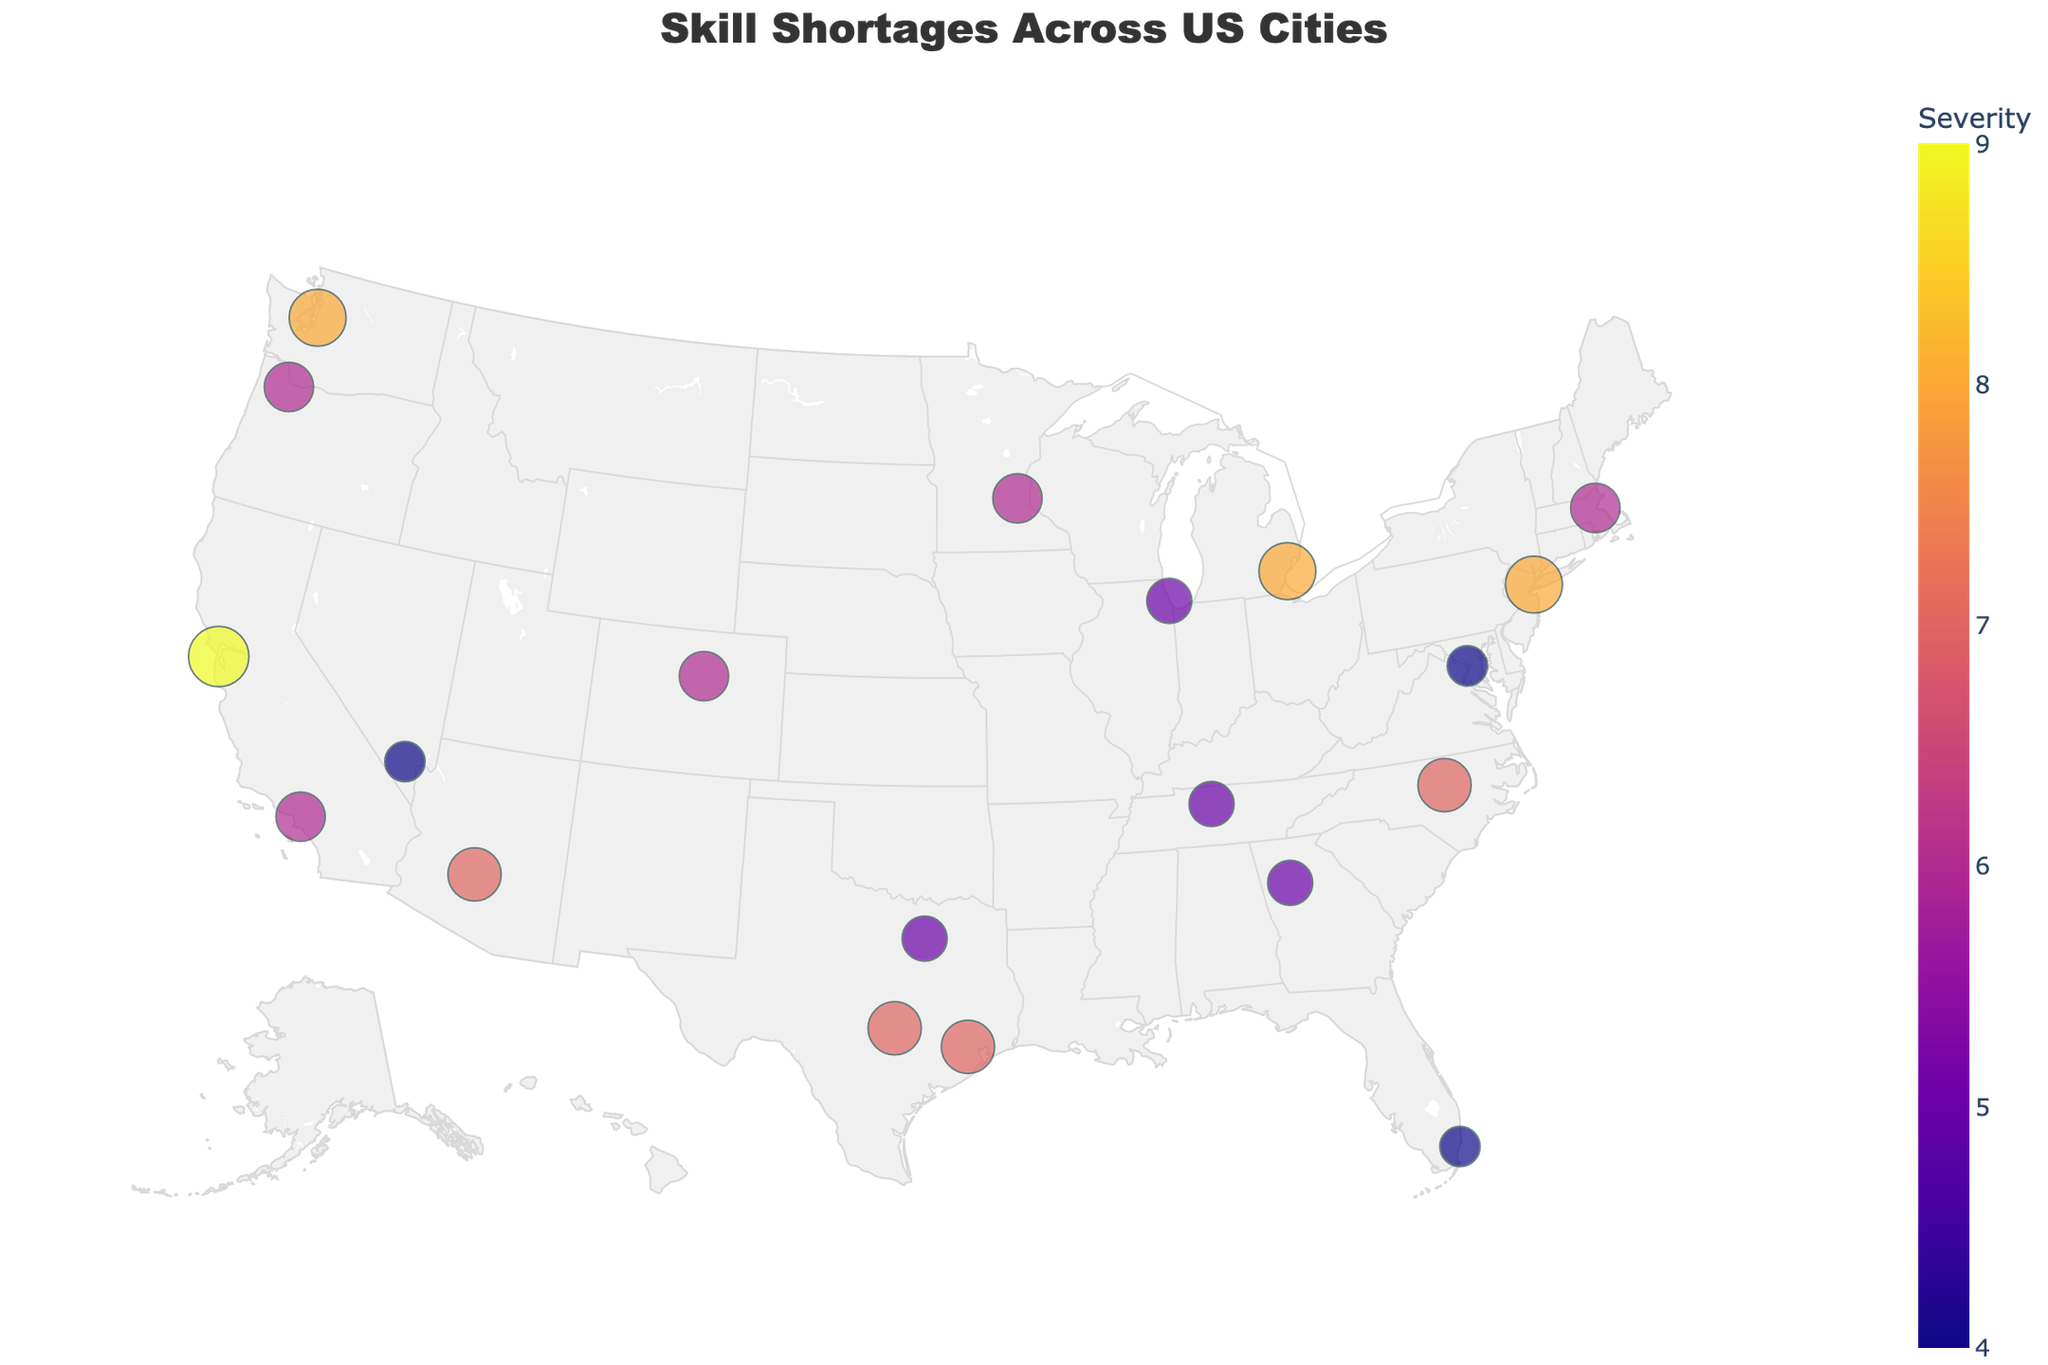What's the title of the plot? The title of the plot is prominently displayed at the top. It helps provide context for what the figure is about.
Answer: Skill Shortages Across US Cities Which city has the highest severity of skill shortages? By looking at the color scale and size of the markers, the city with the highest value on the color scale and the largest marker corresponds to the highest severity.
Answer: San Francisco What skill shortage is identified in New York City, and how severe is it? Hovering over New York City reveals a tooltip with additional information.
Answer: Data Scientists, Severity: 8 Which city has a skill shortage with a severity level of 5? By checking the color and size of the markers, we can identify cities that have the same severity level.
Answer: Chicago, Atlanta, Nashville, Dallas Compare the severity of skill shortages between Boston and Miami. We can compare the color and size of the markers for both cities to determine the severity levels. Boston has a severity marker of 6, while Miami has a severity marker of 4, indicating Boston has a more severe shortage.
Answer: Boston (6) > Miami (4) How many cities have a skill shortage severity level greater than 6? By scanning the markers and their corresponding color and size, we count the cities with severity levels of 7 and above: San Francisco, New York City, Austin, Houston, Phoenix, and Detroit.
Answer: 6 cities What trend can be observed regarding the types of skill shortages in different regions? Observing the types of skill shortages listed in various regions can help identify patterns or trends in the distribution of skill demands. For instance, tech-related skills seem to be in high demand in major tech hubs.
Answer: Major tech hubs like San Francisco and New York City have higher demand for tech skills Is there any city that has a severity level lower than 5, and if so, which city and what skill? By identifying the cities with markers smaller and lighter in color than those with a level of 5, we find such cities.
Answer: Washington D.C., Miami, Las Vegas Which city is experiencing a shortage of UX/UI Designers, and what is the severity? By checking the tooltips for each city or scanning the labeled data points, we find the relevant information.
Answer: Los Angeles, Severity: 6 